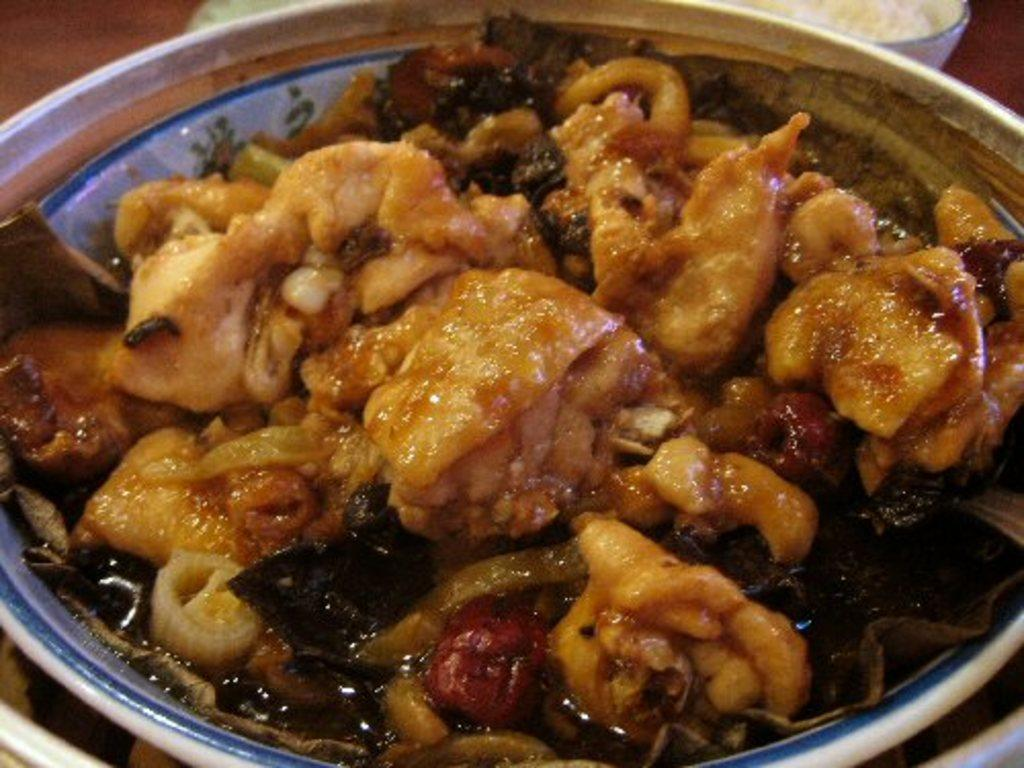What is present in the image? There is a bowl in the image. What is inside the bowl? The bowl contains eatables. Where is the bowl located? The bowl is placed on a table. What type of pancake is being cooked on the stove in the image? There is no stove or pancake present in the image; it only features a bowl containing eatables placed on a table. 